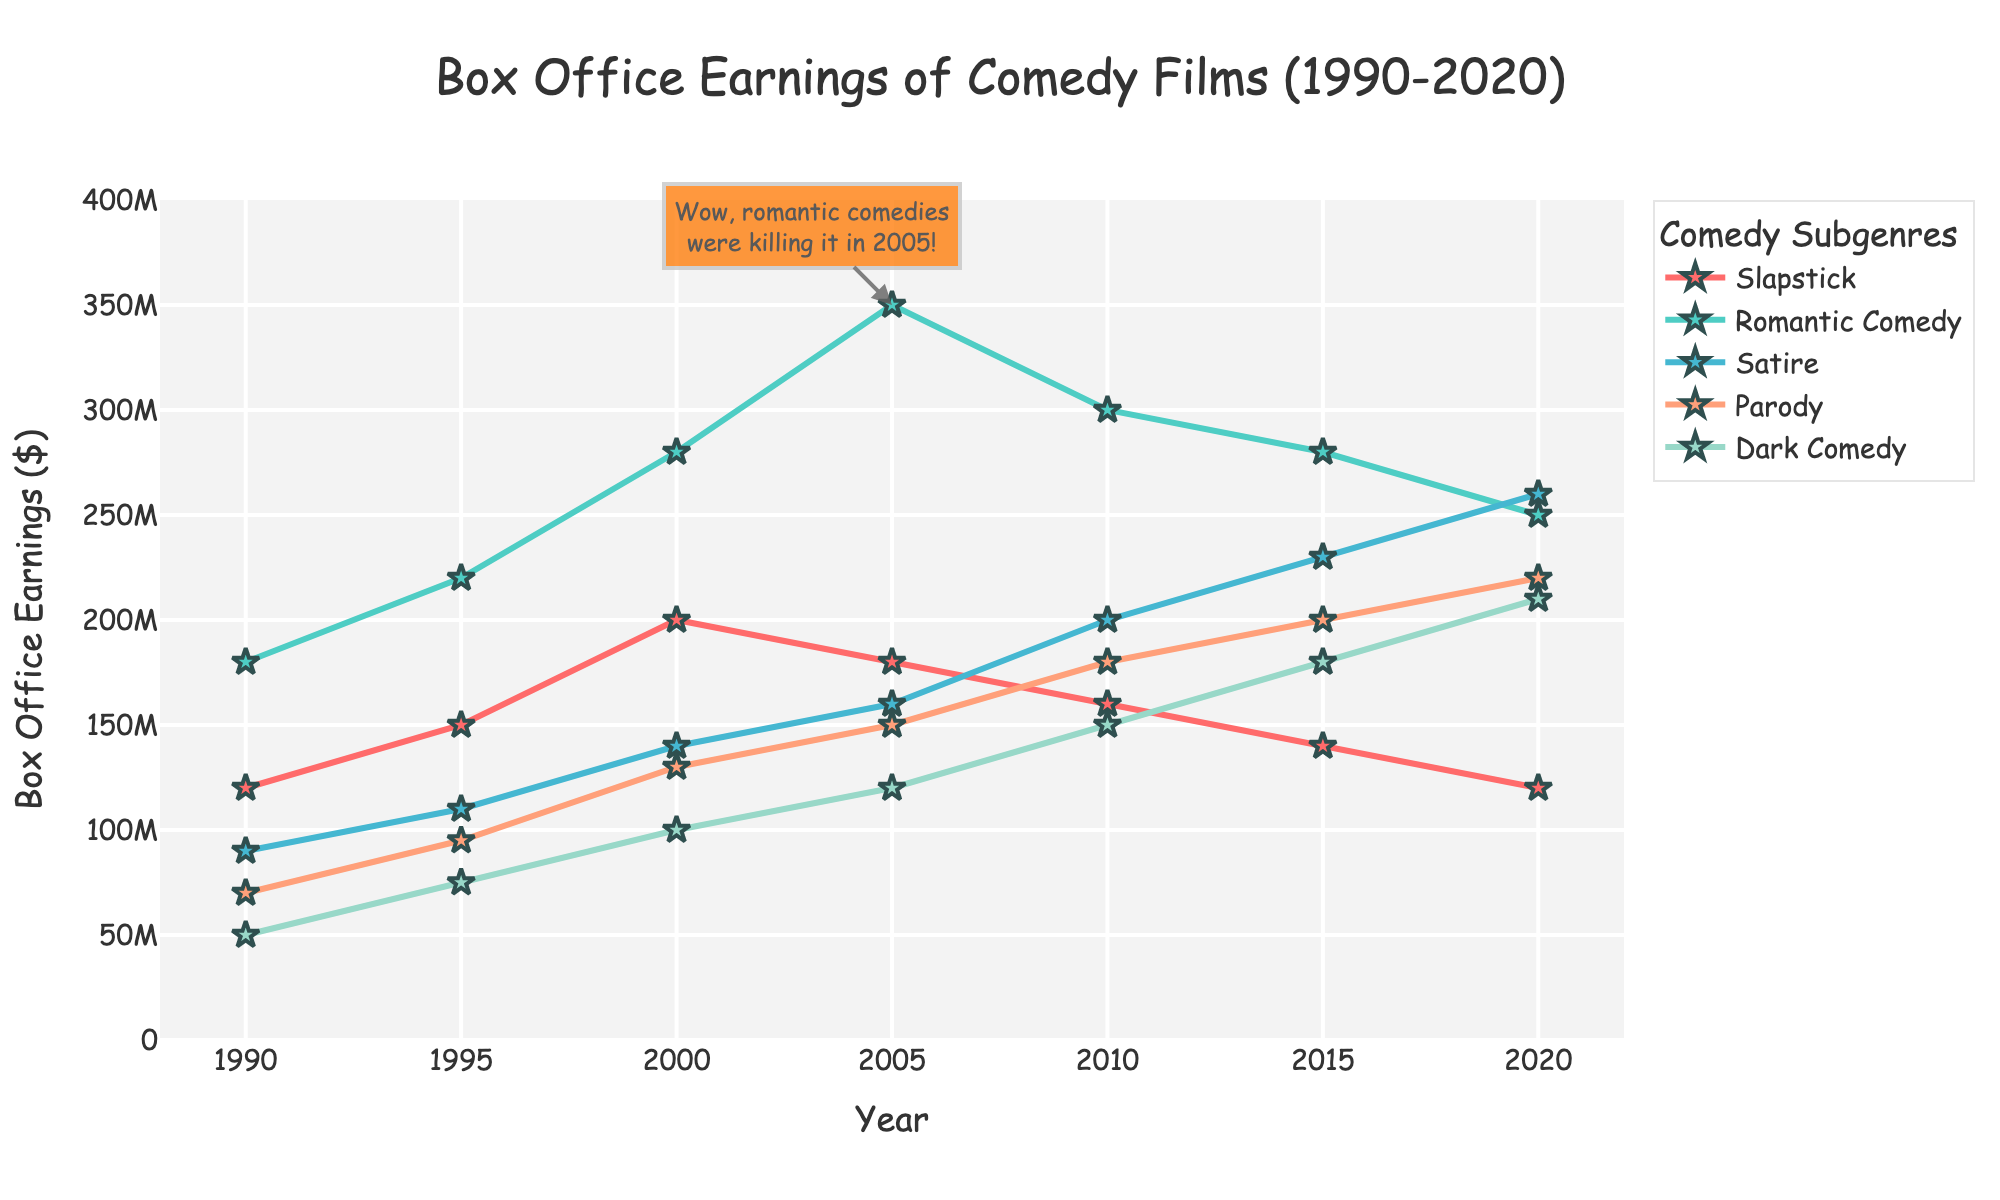What's the highest box office earnings achieved by any comedy subgenre in the entire period? To find the highest earnings, we look at the peaks in the dataset. The plot shows that Romantic Comedy reached $350 million in 2005, which is the highest among all subgenres between 1990 and 2020.
Answer: $350 million Which subgenre showed the most consistent growth in box office earnings from 1990 to 2020? Consistent growth means examining if the earnings trend continuously increases over the years. Satire shows a steady increase from $90 million in 1990 to $260 million in 2020, with each interval moving upwards, without any decline.
Answer: Satire In which year did Romantic Comedy experience its maximum box office earnings? By looking at the peak points for Romantic Comedy's line on the plot, we see it reaches its highest earnings in 2005 at $350 million.
Answer: 2005 Compare the box office earnings of Slapstick and Dark Comedy in 2005; which one is higher and by how much? From the plot, in 2005, Slapstick earned $180 million, and Dark Comedy earned $120 million. The difference is $180 million - $120 million. Thus, Slapstick earned $60 million more than Dark Comedy.
Answer: Slapstick by $60 million What is the total box office earning of Romantic Comedy from 1990 to 2020? Adding the box office earnings of Romantic Comedy for each year: $180 million + $220 million + $280 million + $350 million + $300 million + $280 million + $250 million = $1,860 million.
Answer: $1,860 million Which subgenre had the lowest earnings in 1990, and how much was it? In 1990, the plot shows the lowest point corresponds to Dark Comedy, which earned $50 million, the lowest among all subgenres.
Answer: Dark Comedy, $50 million What was the average box office earning of Dark Comedy over the three decades? Average earning of Dark Comedy is calculated by summing the earnings across the years and dividing by the number of years: 
($50 million + $75 million + $100 million + $120 million + $150 million + $180 million + $210 million) / 7 = $128.57 million.
Answer: $128.57 million 